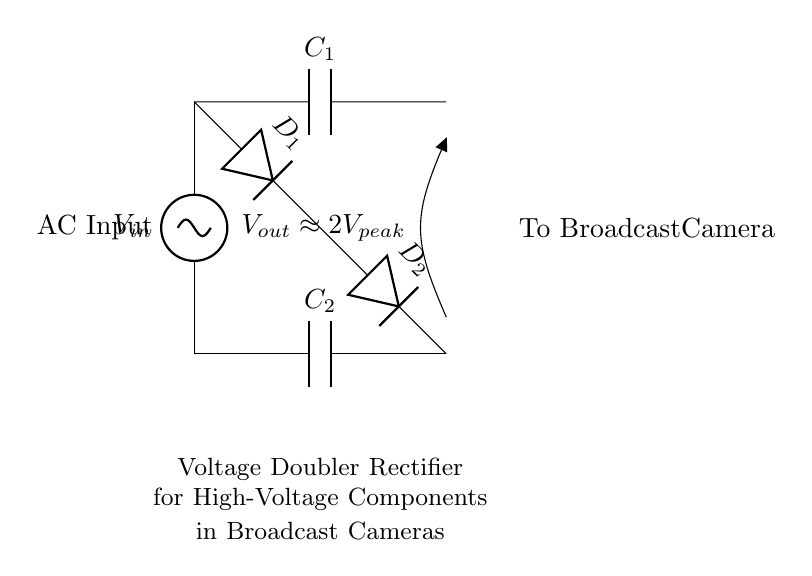What is the input voltage type in this circuit? The input voltage type is alternating current (AC), as indicated by the labeling at the beginning of the circuit diagram.
Answer: AC What does the output voltage approximate to? The output voltage is labeled as approximately two times the peak input voltage, as shown in the diagram.
Answer: 2V peak What are the two diodes in this circuit? The diodes are labeled D1 and D2, which are responsible for rectifying the AC input into a higher DC output voltage.
Answer: D1, D2 What is the purpose of capacitor C1? Capacitor C1 plays a critical role in charging and storing energy during the rectification process for smoothing the output voltage.
Answer: Energy storage How does this circuit double the voltage? The configuration of the two diodes and capacitors allows the circuit to add voltages together during the alternating cycle, effectively doubling the output voltage.
Answer: By adding voltages What is the component labeled C2 used for? Capacitor C2 is used to smooth the output voltage by filtering out ripples after rectification, ensuring a steady DC supply to the broadcast camera.
Answer: Smoothing output What is the result of using a voltage doubler rectifier for broadcast cameras? The result is that the broadcast cameras can operate with a higher voltage supply from a lower voltage source, thus powering high-voltage components effectively.
Answer: Higher operating voltage 